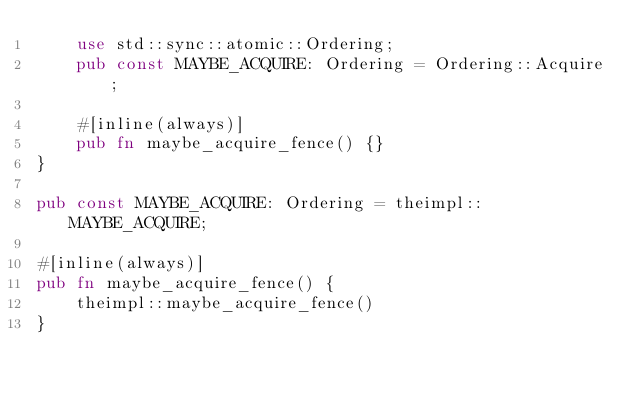<code> <loc_0><loc_0><loc_500><loc_500><_Rust_>    use std::sync::atomic::Ordering;
    pub const MAYBE_ACQUIRE: Ordering = Ordering::Acquire;

    #[inline(always)]
    pub fn maybe_acquire_fence() {}
}

pub const MAYBE_ACQUIRE: Ordering = theimpl::MAYBE_ACQUIRE;

#[inline(always)]
pub fn maybe_acquire_fence() {
    theimpl::maybe_acquire_fence()
}
</code> 